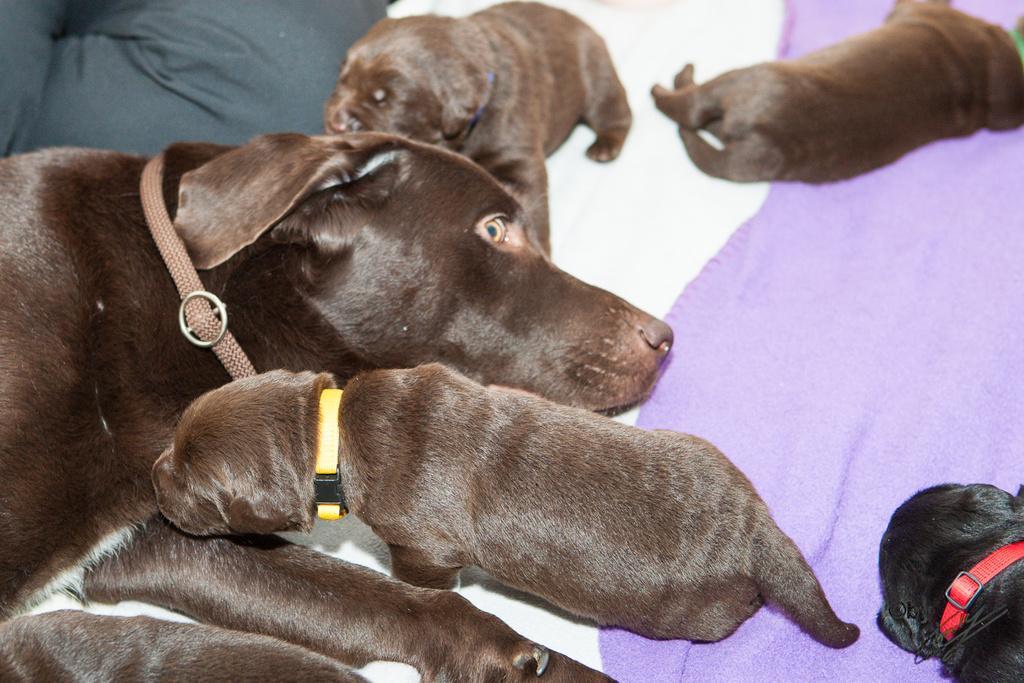How would you summarize this image in a sentence or two? In the picture we can see a dog which is in black color and there are some puppies which are also in black color are resting on the surface. 